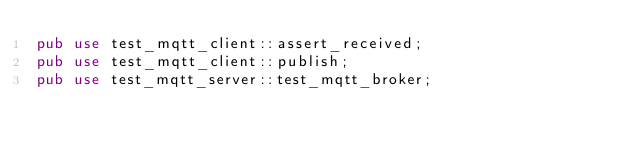Convert code to text. <code><loc_0><loc_0><loc_500><loc_500><_Rust_>pub use test_mqtt_client::assert_received;
pub use test_mqtt_client::publish;
pub use test_mqtt_server::test_mqtt_broker;
</code> 